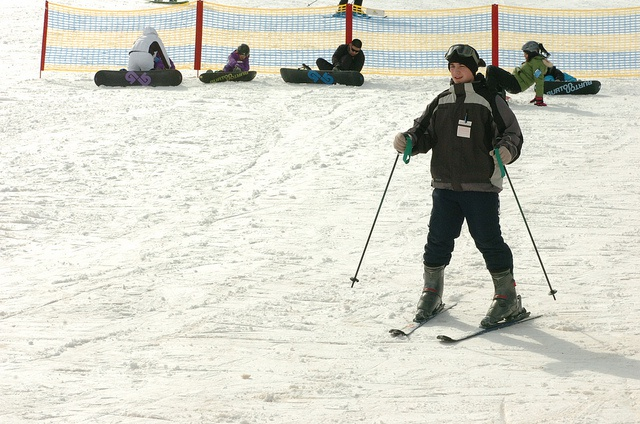Describe the objects in this image and their specific colors. I can see people in white, black, gray, and darkgray tones, people in white, black, darkgreen, and gray tones, people in white, black, gray, darkgray, and ivory tones, snowboard in white, black, and gray tones, and people in white, darkgray, black, lightgray, and gray tones in this image. 